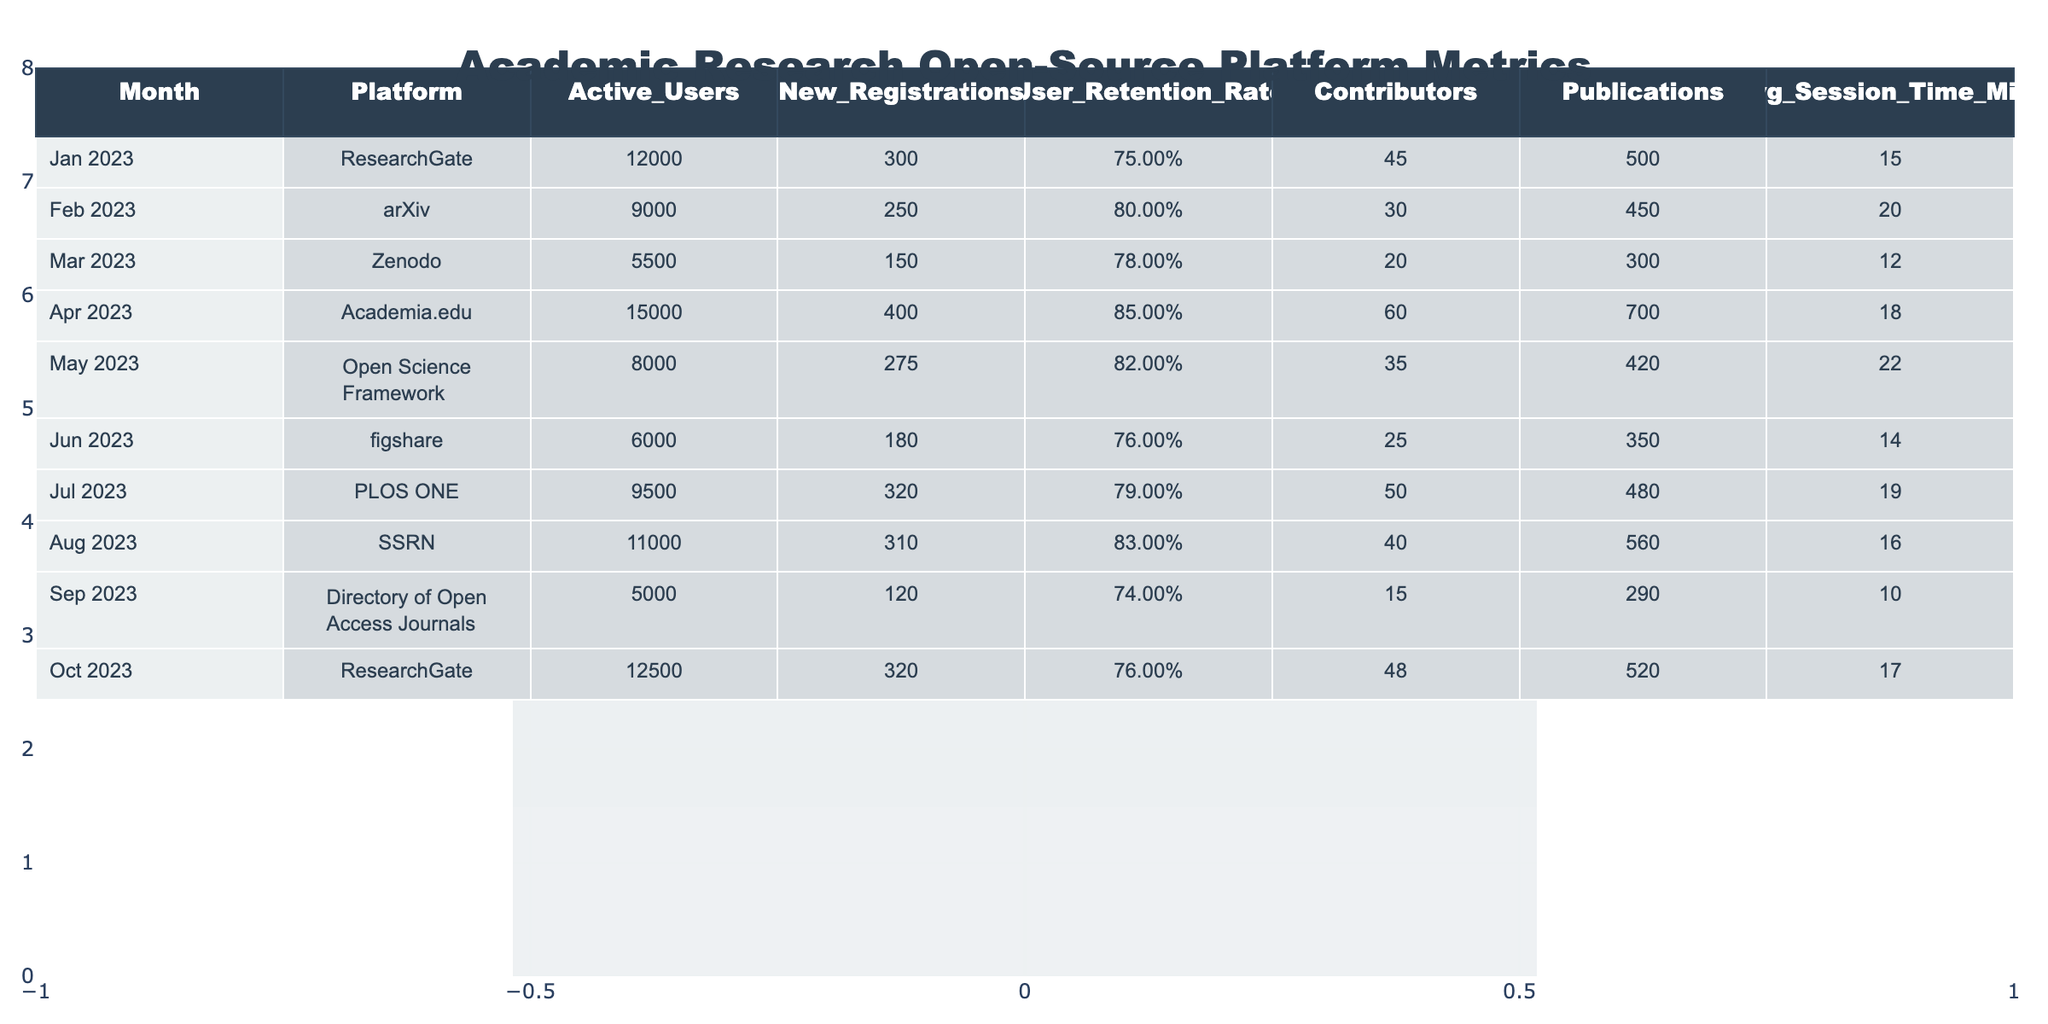What was the highest number of active users in a single month? The highest number of active users in the table is found in April 2023 with 15,000 users.
Answer: 15,000 Which platform had the lowest user retention rate? The platform with the lowest user retention rate is the Directory of Open Access Journals at 0.74.
Answer: 0.74 In which month did the academic research platform experience the highest new registrations? The month with the highest new registrations is April 2023 with 400 new registrations.
Answer: 400 What is the average session time for users in August? The average session time for users in August is 16 minutes.
Answer: 16 Calculate the total number of publications across all platforms for the year. The total number of publications is 500 + 450 + 300 + 700 + 420 + 350 + 480 + 560 + 290 + 520 = 4,570 publications.
Answer: 4,570 Did the Open Science Framework have a higher user retention rate than PLOS ONE? Yes, Open Science Framework had a user retention rate of 0.82, while PLOS ONE had 0.79.
Answer: Yes What was the average number of active users from January to March? The average number of active users from January to March is (12,000 + 9,000 + 5,500) / 3 = 8,833.33, so we round it to approximately 8,833.
Answer: 8,833 In which month did the platform see a decline in active users compared to the previous month? The platform saw a decline in active users from July (9,500) to August (11,000).
Answer: August What is the difference in user retention rate between the highest and the lowest recorded platforms? The difference in user retention rate is 0.85 (Academia.edu) - 0.74 (Directory of Open Access Journals) = 0.11.
Answer: 0.11 Which two months had a similar number of new registrations? February (250) and June (180) had a similar number of new registrations, both showing small variation.
Answer: February and June 